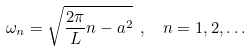Convert formula to latex. <formula><loc_0><loc_0><loc_500><loc_500>\omega _ { n } = \sqrt { \frac { 2 \pi } { L } n - a ^ { 2 } } \ , \ \ n = 1 , 2 , \dots</formula> 